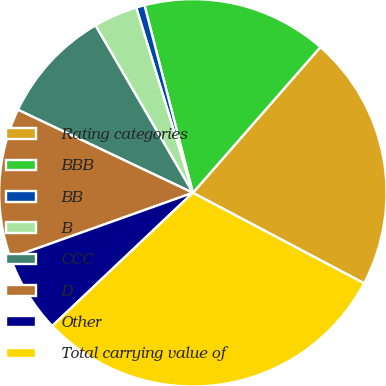Convert chart to OTSL. <chart><loc_0><loc_0><loc_500><loc_500><pie_chart><fcel>Rating categories<fcel>BBB<fcel>BB<fcel>B<fcel>CCC<fcel>D<fcel>Other<fcel>Total carrying value of<nl><fcel>21.3%<fcel>15.46%<fcel>0.71%<fcel>3.66%<fcel>9.56%<fcel>12.51%<fcel>6.61%<fcel>30.2%<nl></chart> 